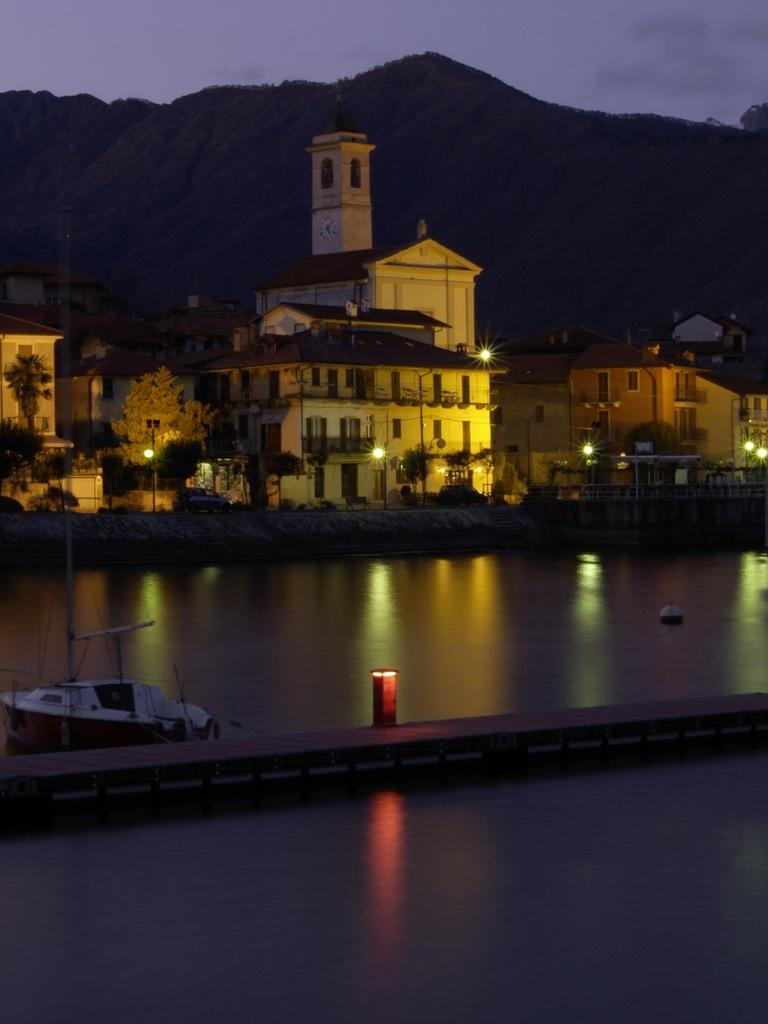What is the main subject of the image? The main subject of the image is a boat. What is the boat situated in? The boat is situated in water. What can be seen in the background of the image? There are houses and mountains in the background of the image. What type of ink is being used to write on the boat in the image? There is no ink or writing present on the boat in the image. Where is the meeting taking place in the image? There is no meeting depicted in the image; it features a boat in water with houses and mountains in the background. 